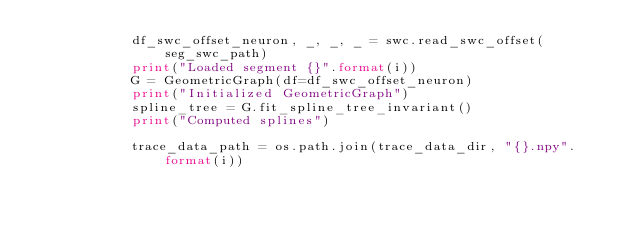<code> <loc_0><loc_0><loc_500><loc_500><_Python_>            df_swc_offset_neuron, _, _, _ = swc.read_swc_offset(seg_swc_path)
            print("Loaded segment {}".format(i))
            G = GeometricGraph(df=df_swc_offset_neuron)
            print("Initialized GeometricGraph")
            spline_tree = G.fit_spline_tree_invariant()
            print("Computed splines")

            trace_data_path = os.path.join(trace_data_dir, "{}.npy".format(i))</code> 